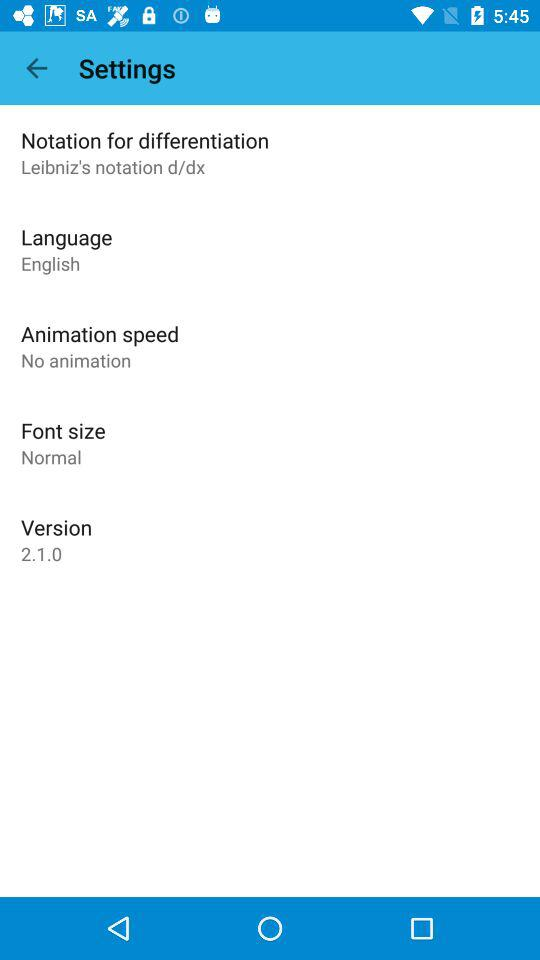What is the version? The version is 2.1.0. 